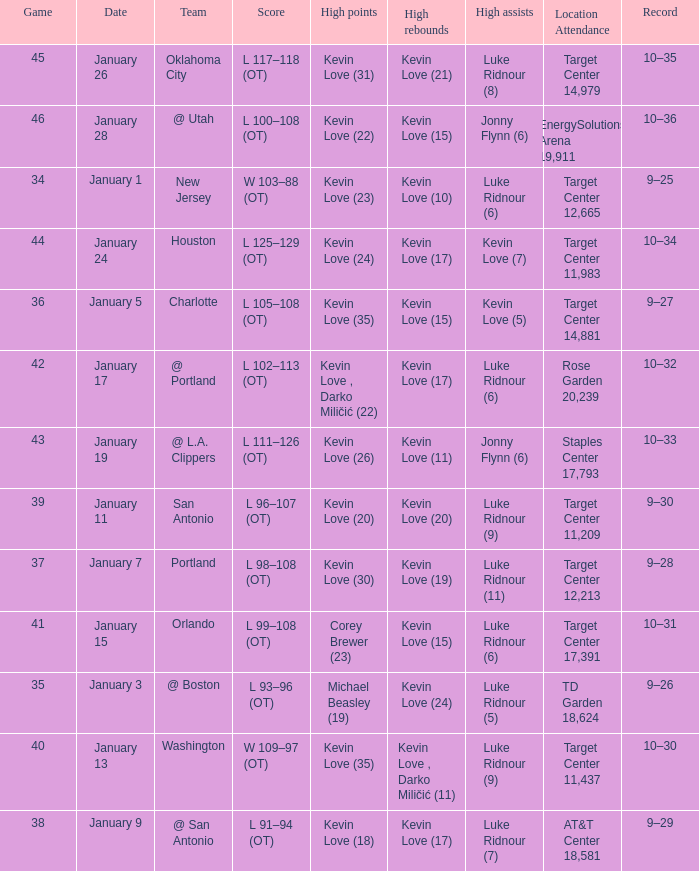What is the date for the game with team orlando? January 15. 